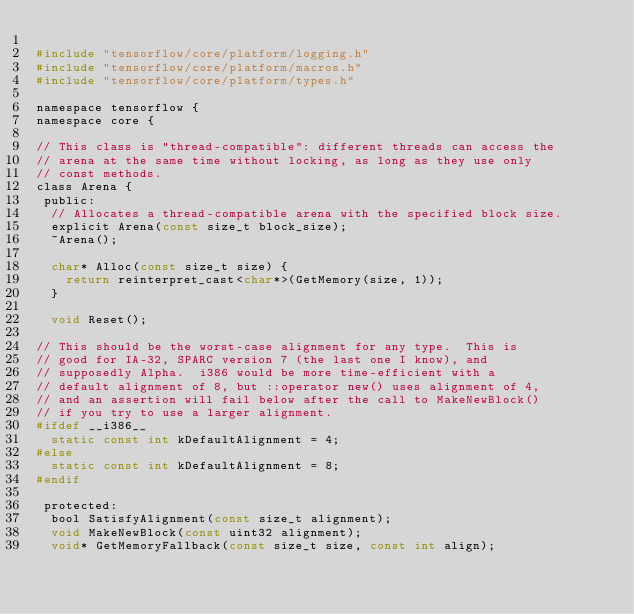Convert code to text. <code><loc_0><loc_0><loc_500><loc_500><_C_>
#include "tensorflow/core/platform/logging.h"
#include "tensorflow/core/platform/macros.h"
#include "tensorflow/core/platform/types.h"

namespace tensorflow {
namespace core {

// This class is "thread-compatible": different threads can access the
// arena at the same time without locking, as long as they use only
// const methods.
class Arena {
 public:
  // Allocates a thread-compatible arena with the specified block size.
  explicit Arena(const size_t block_size);
  ~Arena();

  char* Alloc(const size_t size) {
    return reinterpret_cast<char*>(GetMemory(size, 1));
  }

  void Reset();

// This should be the worst-case alignment for any type.  This is
// good for IA-32, SPARC version 7 (the last one I know), and
// supposedly Alpha.  i386 would be more time-efficient with a
// default alignment of 8, but ::operator new() uses alignment of 4,
// and an assertion will fail below after the call to MakeNewBlock()
// if you try to use a larger alignment.
#ifdef __i386__
  static const int kDefaultAlignment = 4;
#else
  static const int kDefaultAlignment = 8;
#endif

 protected:
  bool SatisfyAlignment(const size_t alignment);
  void MakeNewBlock(const uint32 alignment);
  void* GetMemoryFallback(const size_t size, const int align);</code> 